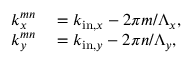Convert formula to latex. <formula><loc_0><loc_0><loc_500><loc_500>\begin{array} { r l } { k _ { x } ^ { m n } } & = k _ { i n , x } - 2 \pi m / \Lambda _ { x } , } \\ { k _ { y } ^ { m n } } & = k _ { i n , y } - 2 \pi n / \Lambda _ { y } , } \end{array}</formula> 